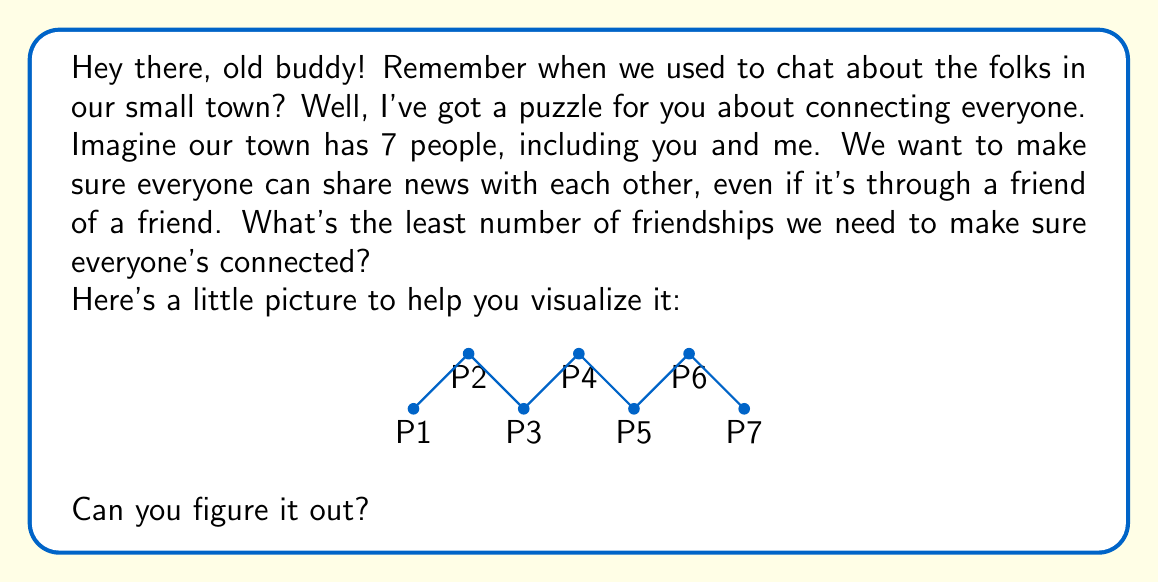What is the answer to this math problem? Alright, let's think this through step-by-step:

1) In graph theory, this problem is about finding the minimum spanning tree of a complete graph with 7 vertices.

2) A tree is a connected graph with no cycles. It's the most efficient way to connect all vertices.

3) A key property of trees is that the number of edges is always one less than the number of vertices. We can express this mathematically as:

   $$ E = V - 1 $$

   Where $E$ is the number of edges (friendships) and $V$ is the number of vertices (people).

4) In our case, we have 7 people (vertices), so:

   $$ E = 7 - 1 = 6 $$

5) The diagram in the question shows one possible way to connect all 7 people with 6 friendships, forming a path graph.

6) This is indeed the minimum number of friendships needed. If we had fewer than 6, the graph would not be connected (some people would be isolated).

So, we need at least 6 friendships to make sure everyone in our little town of 7 people can communicate with each other, even if it's through a chain of friends.
Answer: 6 friendships 